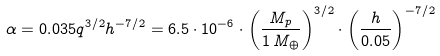Convert formula to latex. <formula><loc_0><loc_0><loc_500><loc_500>\alpha = 0 . 0 3 5 q ^ { 3 / 2 } h ^ { - 7 / 2 } = 6 . 5 \cdot 1 0 ^ { - 6 } \cdot \left ( \frac { M _ { p } } { 1 \, M _ { \oplus } } \right ) ^ { 3 / 2 } \cdot \left ( \frac { h } { 0 . 0 5 } \right ) ^ { - 7 / 2 }</formula> 